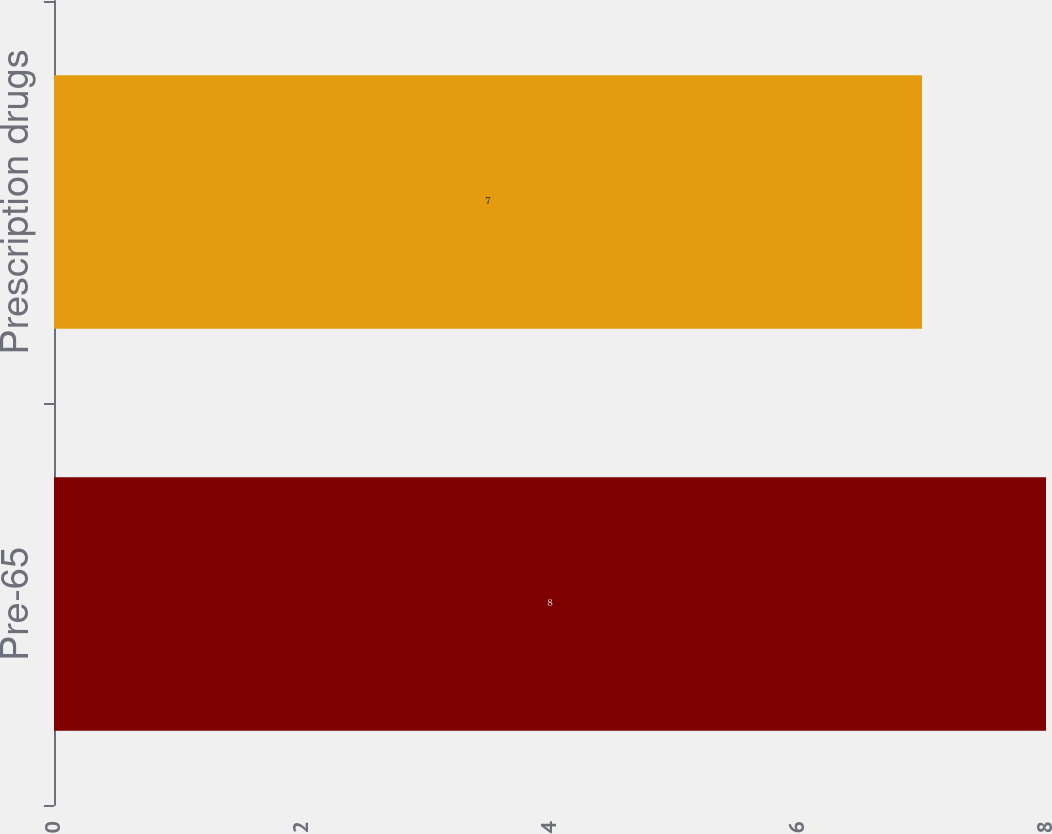Convert chart. <chart><loc_0><loc_0><loc_500><loc_500><bar_chart><fcel>Pre-65<fcel>Prescription drugs<nl><fcel>8<fcel>7<nl></chart> 